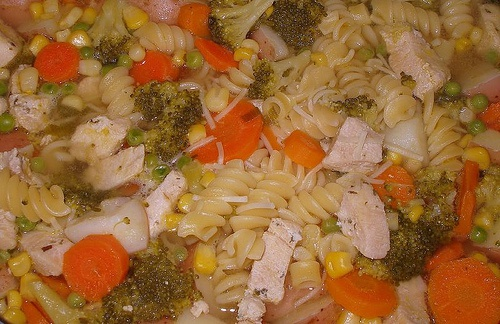Describe the objects in this image and their specific colors. I can see broccoli in brown, maroon, olive, and black tones, carrot in brown and maroon tones, carrot in brown, red, and maroon tones, broccoli in brown, olive, maroon, and gray tones, and carrot in brown and red tones in this image. 